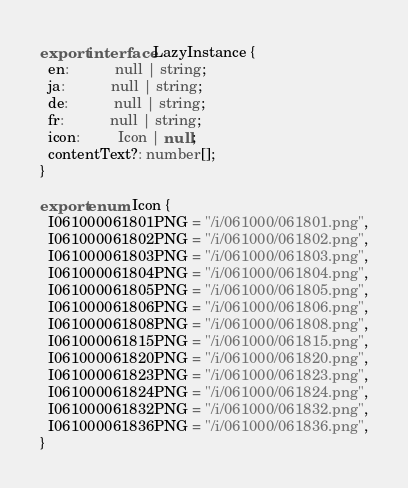Convert code to text. <code><loc_0><loc_0><loc_500><loc_500><_TypeScript_>export interface LazyInstance {
  en:           null | string;
  ja:           null | string;
  de:           null | string;
  fr:           null | string;
  icon:         Icon | null;
  contentText?: number[];
}

export enum Icon {
  I061000061801PNG = "/i/061000/061801.png",
  I061000061802PNG = "/i/061000/061802.png",
  I061000061803PNG = "/i/061000/061803.png",
  I061000061804PNG = "/i/061000/061804.png",
  I061000061805PNG = "/i/061000/061805.png",
  I061000061806PNG = "/i/061000/061806.png",
  I061000061808PNG = "/i/061000/061808.png",
  I061000061815PNG = "/i/061000/061815.png",
  I061000061820PNG = "/i/061000/061820.png",
  I061000061823PNG = "/i/061000/061823.png",
  I061000061824PNG = "/i/061000/061824.png",
  I061000061832PNG = "/i/061000/061832.png",
  I061000061836PNG = "/i/061000/061836.png",
}
</code> 